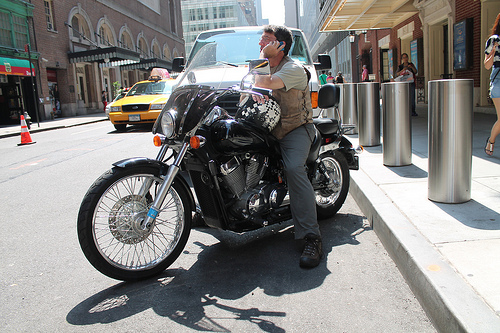What indications are there of the time of day? The length and direction of the shadows cast by the motorcycle and people on the sidewalk suggest it could be midday or early afternoon. 